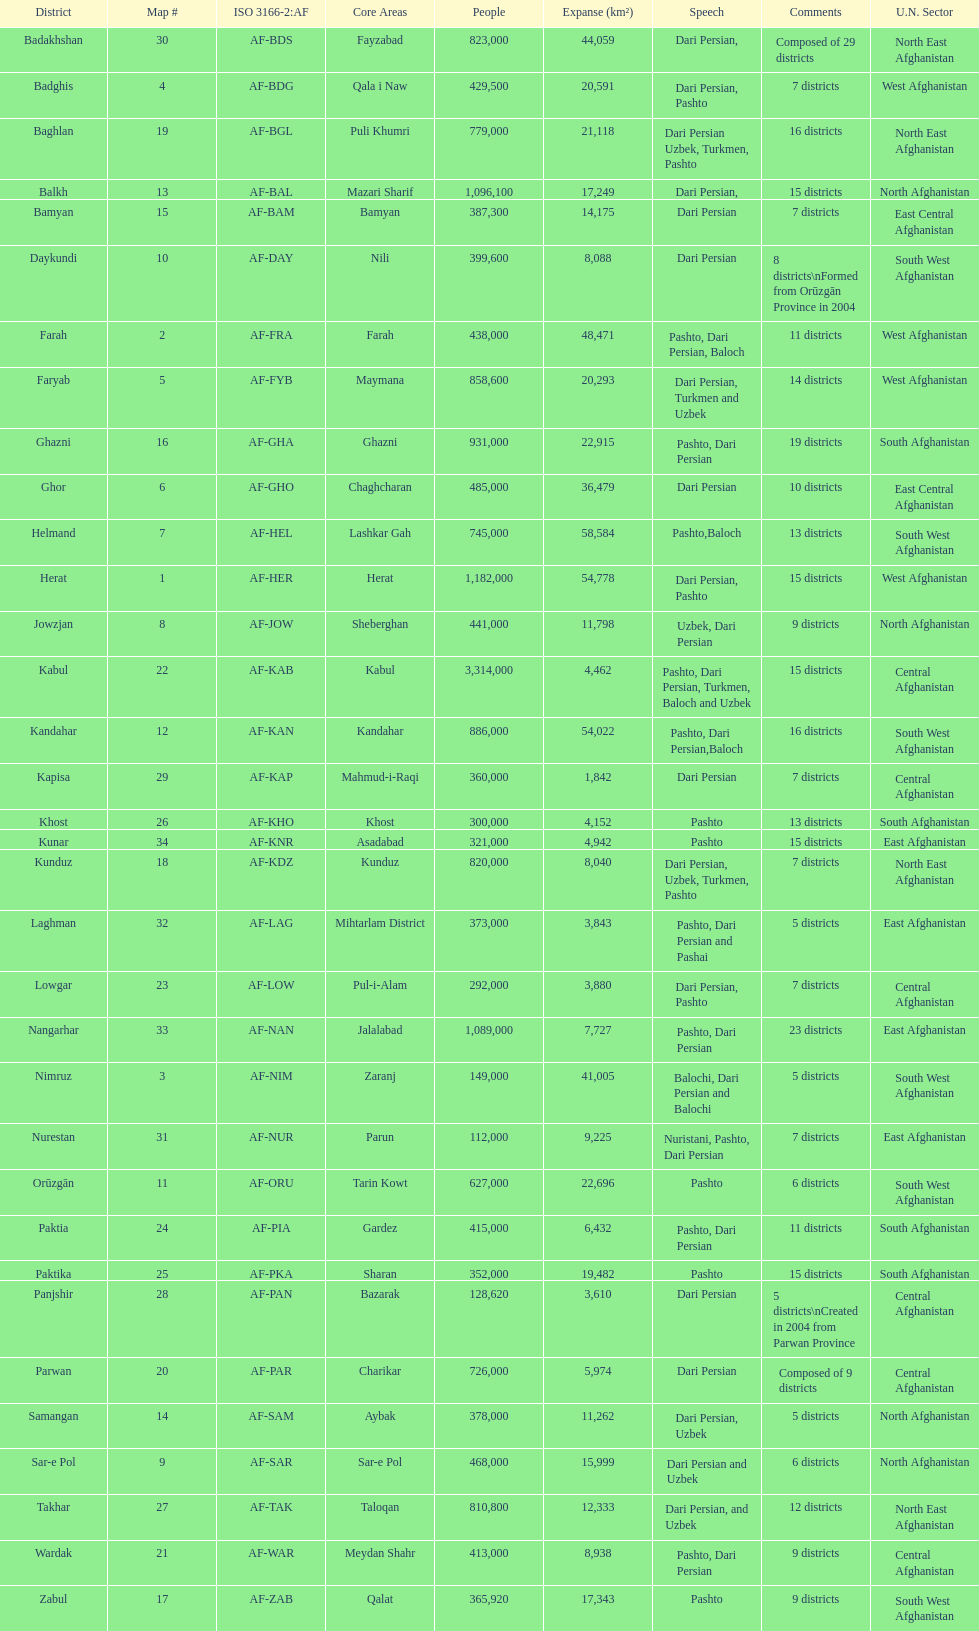Does ghor or farah have more districts? Farah. 